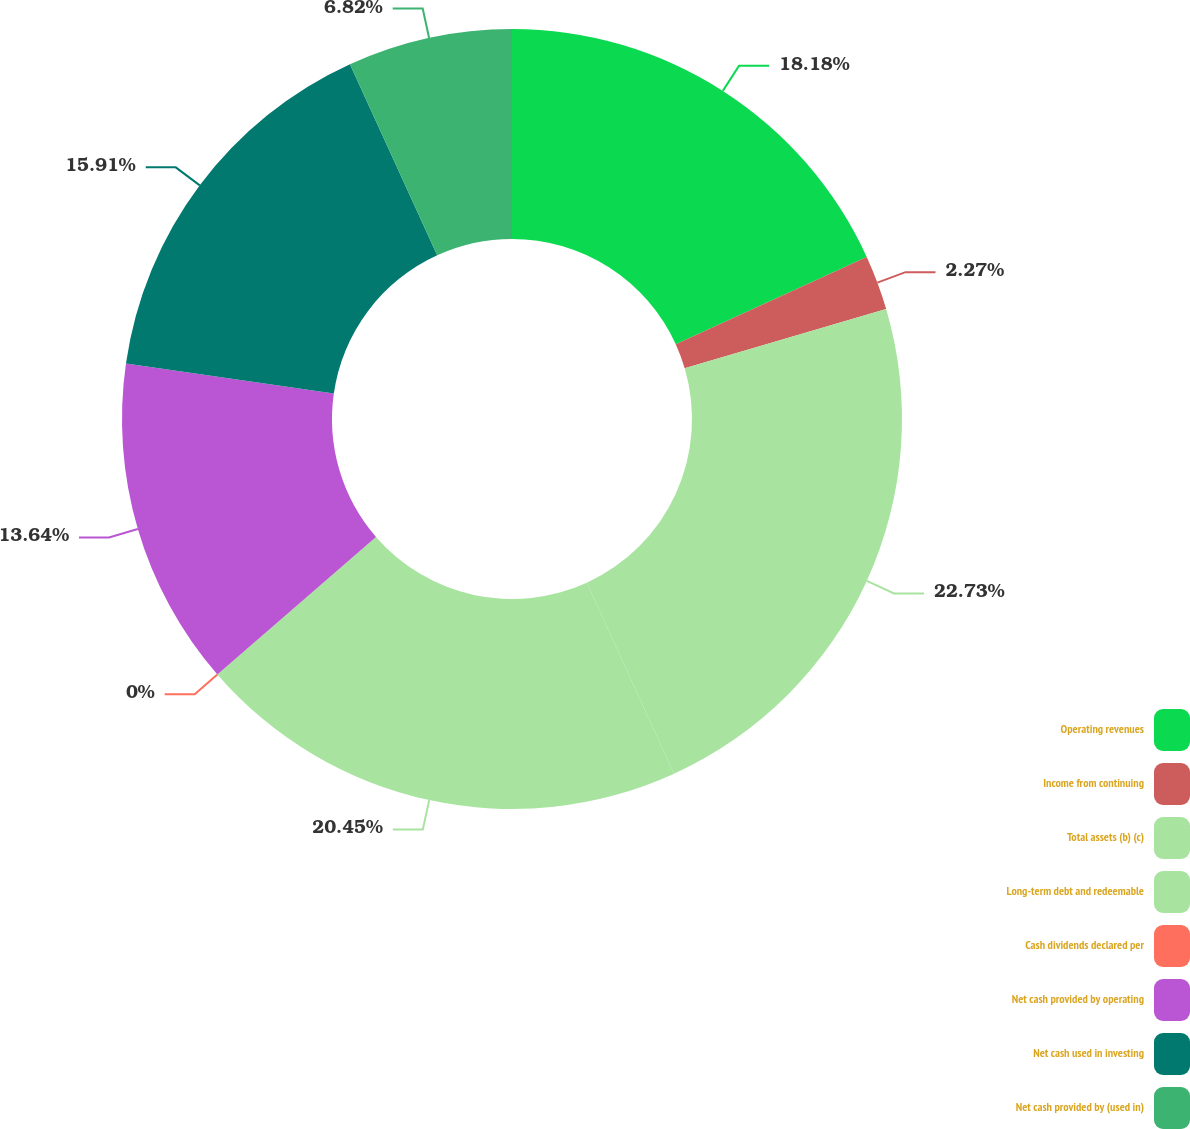Convert chart to OTSL. <chart><loc_0><loc_0><loc_500><loc_500><pie_chart><fcel>Operating revenues<fcel>Income from continuing<fcel>Total assets (b) (c)<fcel>Long-term debt and redeemable<fcel>Cash dividends declared per<fcel>Net cash provided by operating<fcel>Net cash used in investing<fcel>Net cash provided by (used in)<nl><fcel>18.18%<fcel>2.27%<fcel>22.73%<fcel>20.45%<fcel>0.0%<fcel>13.64%<fcel>15.91%<fcel>6.82%<nl></chart> 